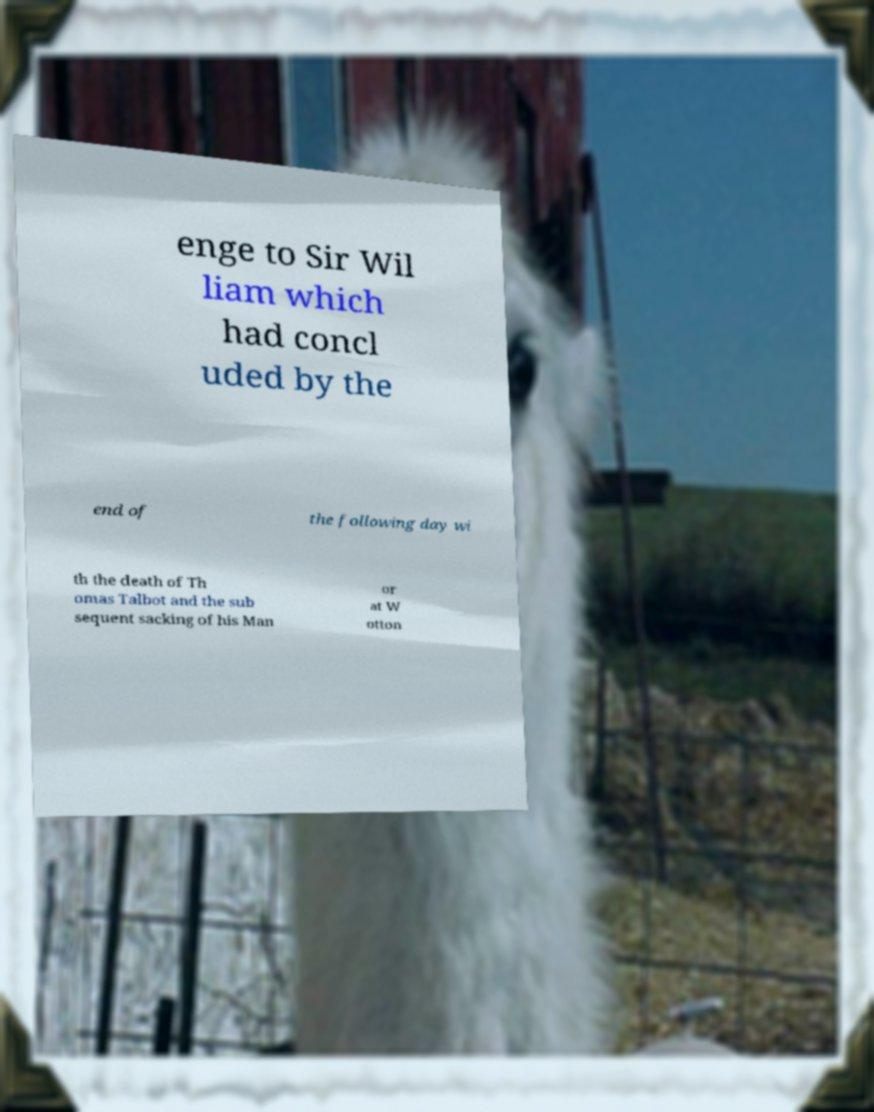Please read and relay the text visible in this image. What does it say? enge to Sir Wil liam which had concl uded by the end of the following day wi th the death of Th omas Talbot and the sub sequent sacking of his Man or at W otton 